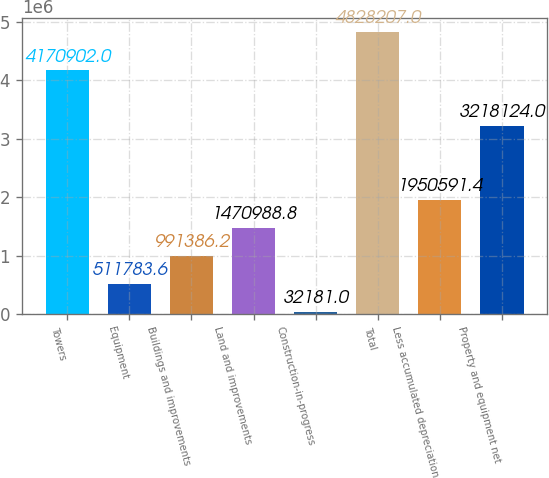<chart> <loc_0><loc_0><loc_500><loc_500><bar_chart><fcel>Towers<fcel>Equipment<fcel>Buildings and improvements<fcel>Land and improvements<fcel>Construction-in-progress<fcel>Total<fcel>Less accumulated depreciation<fcel>Property and equipment net<nl><fcel>4.1709e+06<fcel>511784<fcel>991386<fcel>1.47099e+06<fcel>32181<fcel>4.82821e+06<fcel>1.95059e+06<fcel>3.21812e+06<nl></chart> 